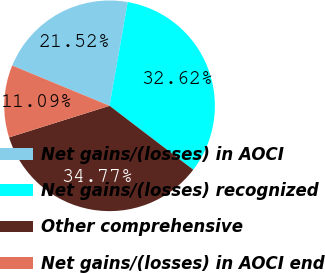Convert chart. <chart><loc_0><loc_0><loc_500><loc_500><pie_chart><fcel>Net gains/(losses) in AOCI<fcel>Net gains/(losses) recognized<fcel>Other comprehensive<fcel>Net gains/(losses) in AOCI end<nl><fcel>21.52%<fcel>32.62%<fcel>34.77%<fcel>11.09%<nl></chart> 